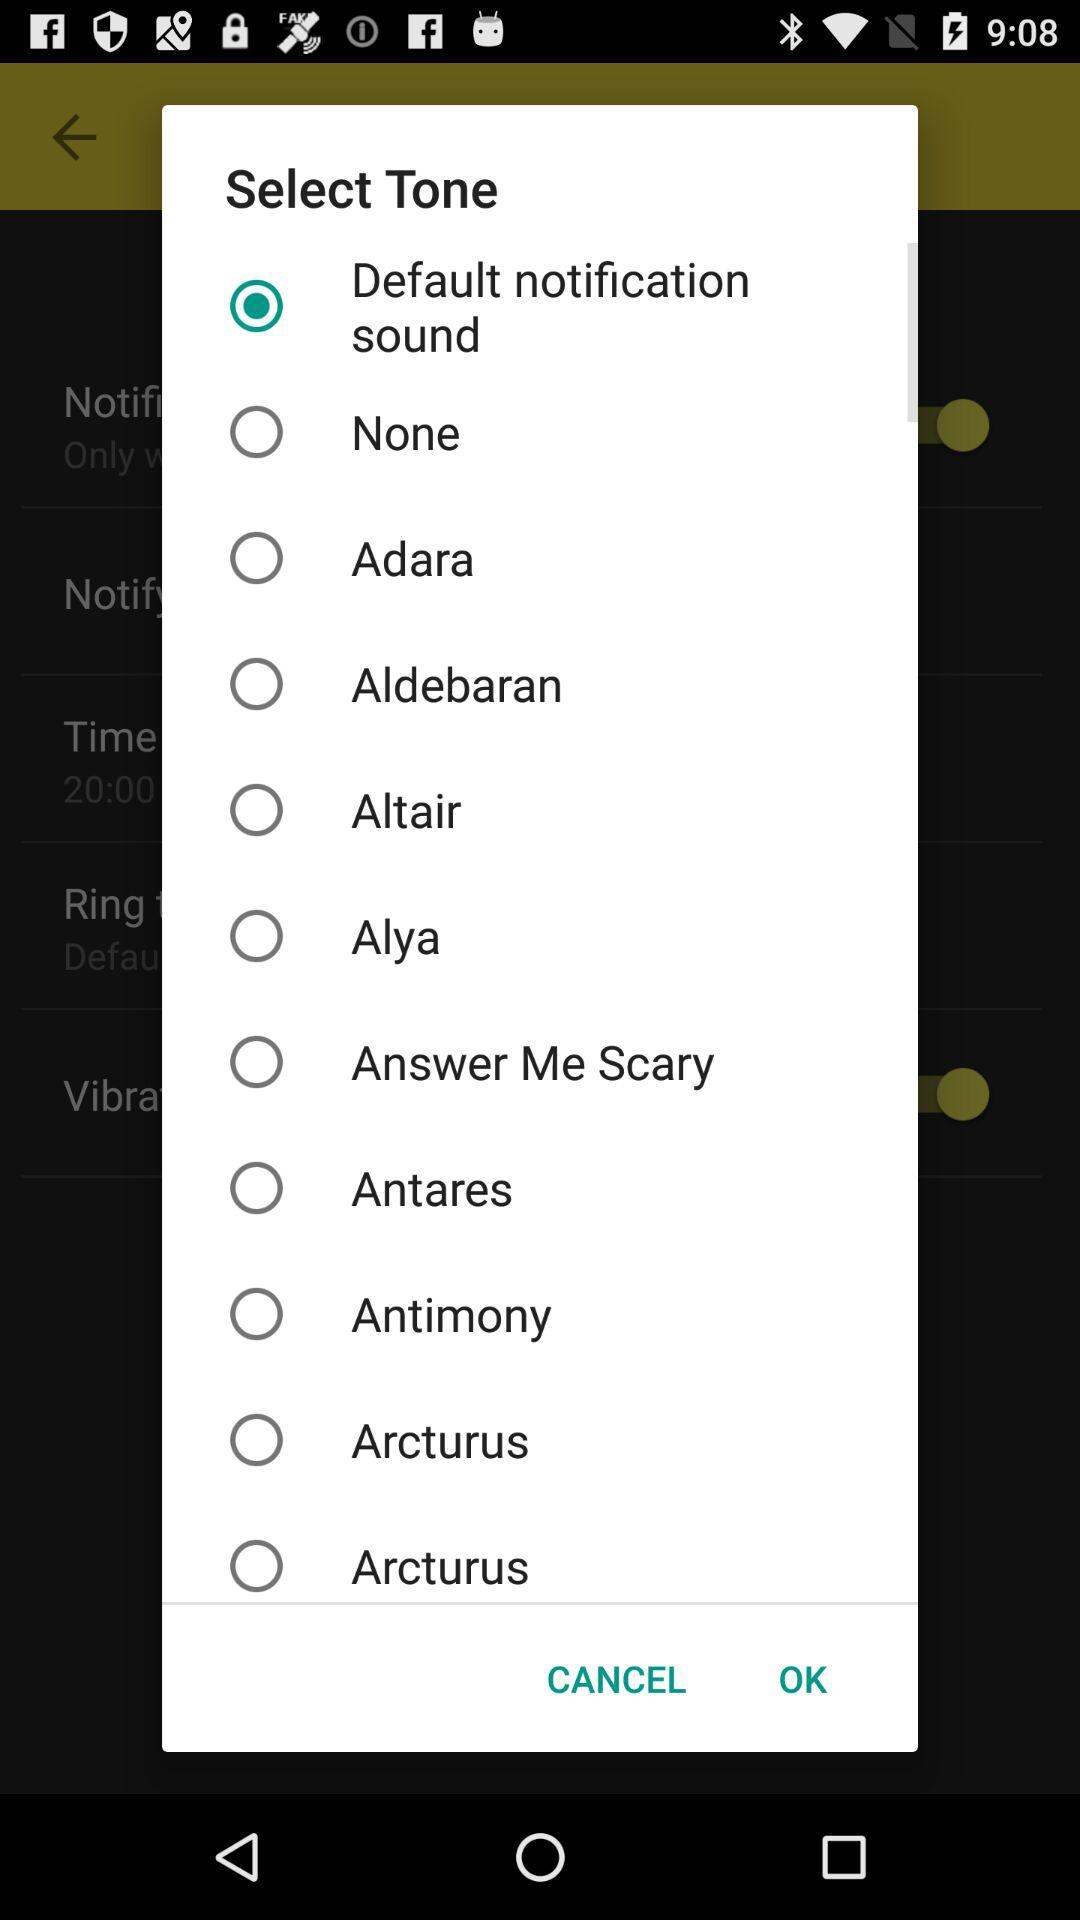Is "Alya" selected or not? "Alya" is not selected. 